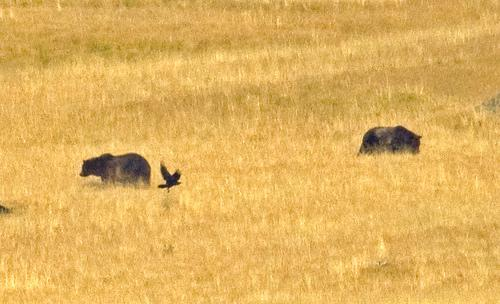Question: how many birds are in this photo?
Choices:
A. Two.
B. Three.
C. None.
D. One.
Answer with the letter. Answer: D Question: what color is the grass?
Choices:
A. Green.
B. Brown.
C. Black.
D. Yellow.
Answer with the letter. Answer: D Question: what color are the bears?
Choices:
A. Black.
B. Grey.
C. Tan.
D. Brown.
Answer with the letter. Answer: D Question: how many bears are in this photo?
Choices:
A. None.
B. Two.
C. One.
D. Three.
Answer with the letter. Answer: B 